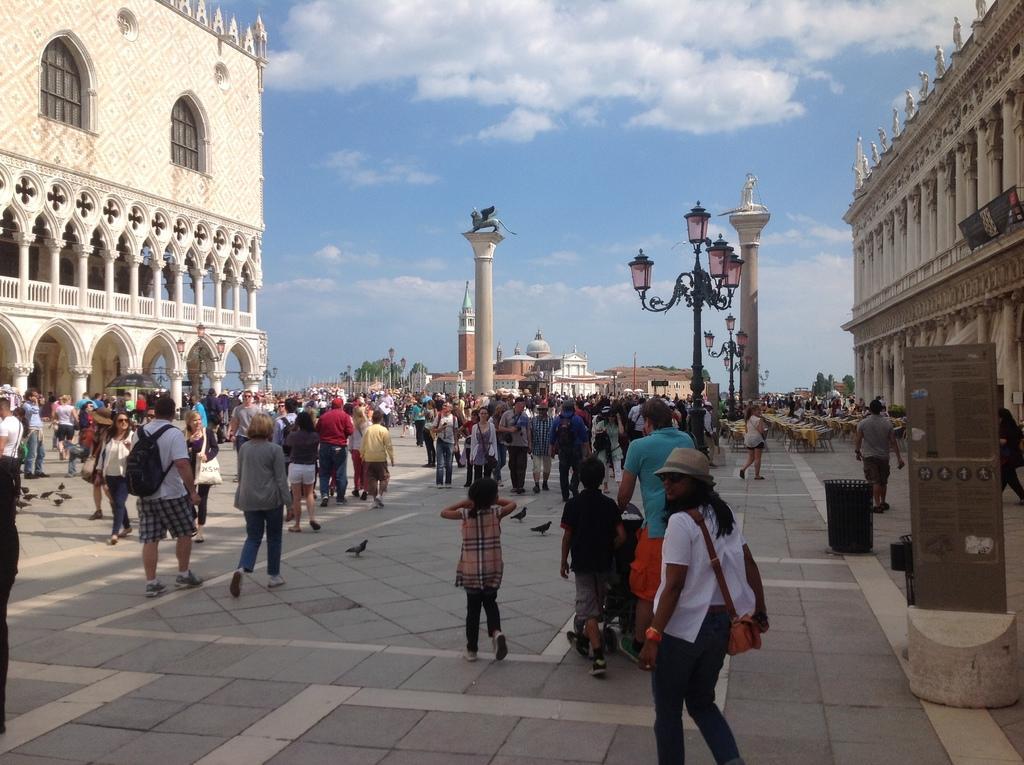Could you give a brief overview of what you see in this image? In the center of the image we can see a pillar and statue. On the right side of the image we can see a light pole, a statue pillar, building, chairs and group of persons. On the left side of the image we can see a building, group of persons, umbrella. In the background there is a castle, sky and clouds. 